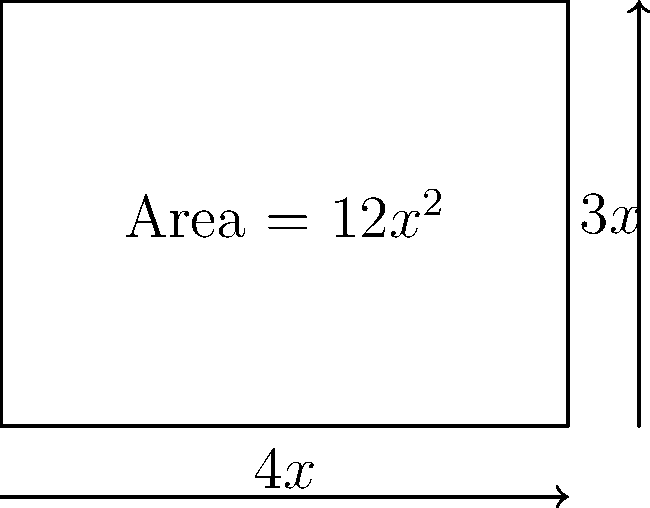As part of your ecotourism project, you need to fence a rectangular field within the wildlife reserve to create a protected area for rare plant species. The total area of the field is $12x^2$ square meters, where $x$ is a variable. The length of the field is $4x$ meters, and its width is $3x$ meters. What is the total length of fencing required to enclose this field, expressed in terms of $x$? Let's approach this step-by-step:

1) We're given that the field is rectangular with:
   - Area = $12x^2$ square meters
   - Length = $4x$ meters
   - Width = $3x$ meters

2) To find the total length of fencing, we need to calculate the perimeter of the rectangle.

3) The formula for the perimeter of a rectangle is:
   $P = 2l + 2w$, where $l$ is length and $w$ is width

4) Substituting our values:
   $P = 2(4x) + 2(3x)$

5) Simplifying:
   $P = 8x + 6x$
   $P = 14x$

Therefore, the total length of fencing required is $14x$ meters.
Answer: $14x$ meters 